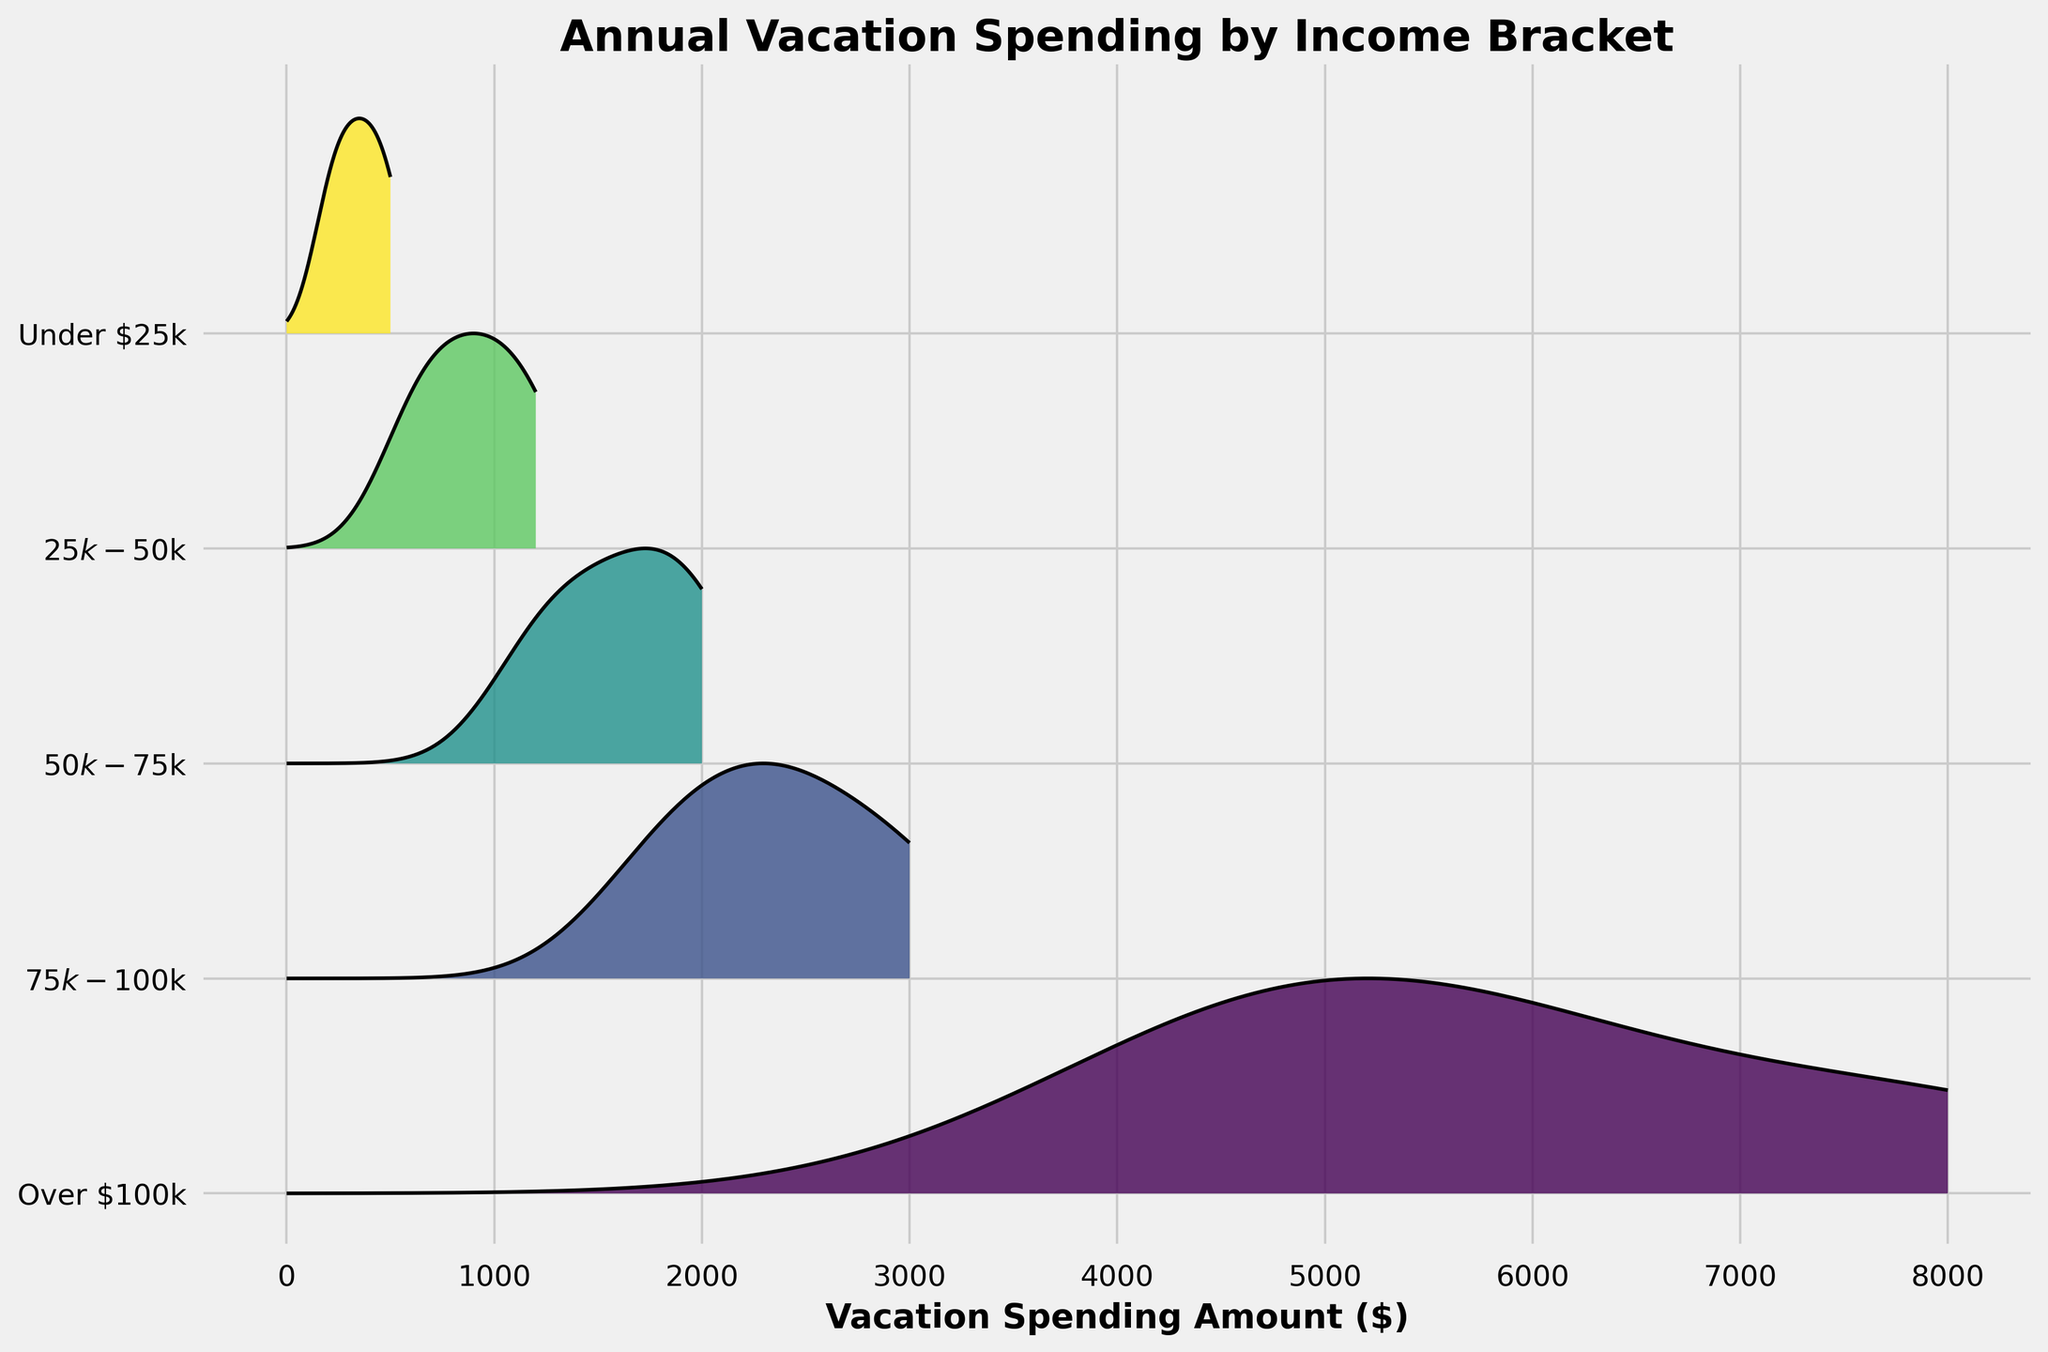What is the title of the plot? The title of the plot is located at the top of the figure and reads 'Annual Vacation Spending by Income Bracket'.
Answer: Annual Vacation Spending by Income Bracket Which income bracket shows the highest spending amount? By examining the layers of the plot, the 'Over $100k' income bracket reaches the furthest on the x-axis, indicating the highest spending amount.
Answer: Over $100k How are the income brackets visually distinguished in the plot? The income brackets are distinguished by different layers and colors, with each bracket represented by a distinct layer along the y-axis.
Answer: Different layers and colors What does the x-axis represent? The x-axis of the plot represents the vacation spending amount in dollars ($).
Answer: Vacation spending amount ($) Which income bracket has the widest range of spending amounts? The 'Over $100k' bracket extends the farthest on the x-axis, indicating it has the widest range of vacation spending amounts.
Answer: Over $100k How does the spending amount for the 'Under $25k' bracket compare to the '$75k-$100k' bracket for vacations? The plot shows that the peak spending amount in the 'Under $25k' bracket is significantly lower and concentrated to the left compared to the '$75k-$100k' bracket, which extends much further to the right on the x-axis.
Answer: Lower in 'Under $25k' What is the trend observed as income increases in relation to vacation spending? By observing the layers from bottom to top, we see that as income increases, the range and peak of vacation spending amounts tend to increase.
Answer: Spending increases with income What does the positioning of the 'Over $100k' bracket along the x-axis imply about their spending habits? The farthest extension to the right and uppermost position of the 'Over $100k' bracket suggests that this group spends the most on vacations compared to lower income brackets.
Answer: Highest spending Are there any income brackets that show a similar spending pattern? The 'Under $25k' and '$25k-$50k' brackets show spending patterns that peak at similar low amounts, indicating more modest vacation spending compared to higher income brackets.
Answer: 'Under $25k' and '$25k-$50k' Is there any noticeable difference in the distribution shape between lower and higher income brackets? Lower income brackets have narrower distribution shapes and peaks closer to the origin, whereas higher income brackets have wider distributions spread further along the x-axis.
Answer: Yes, wider for higher incomes 